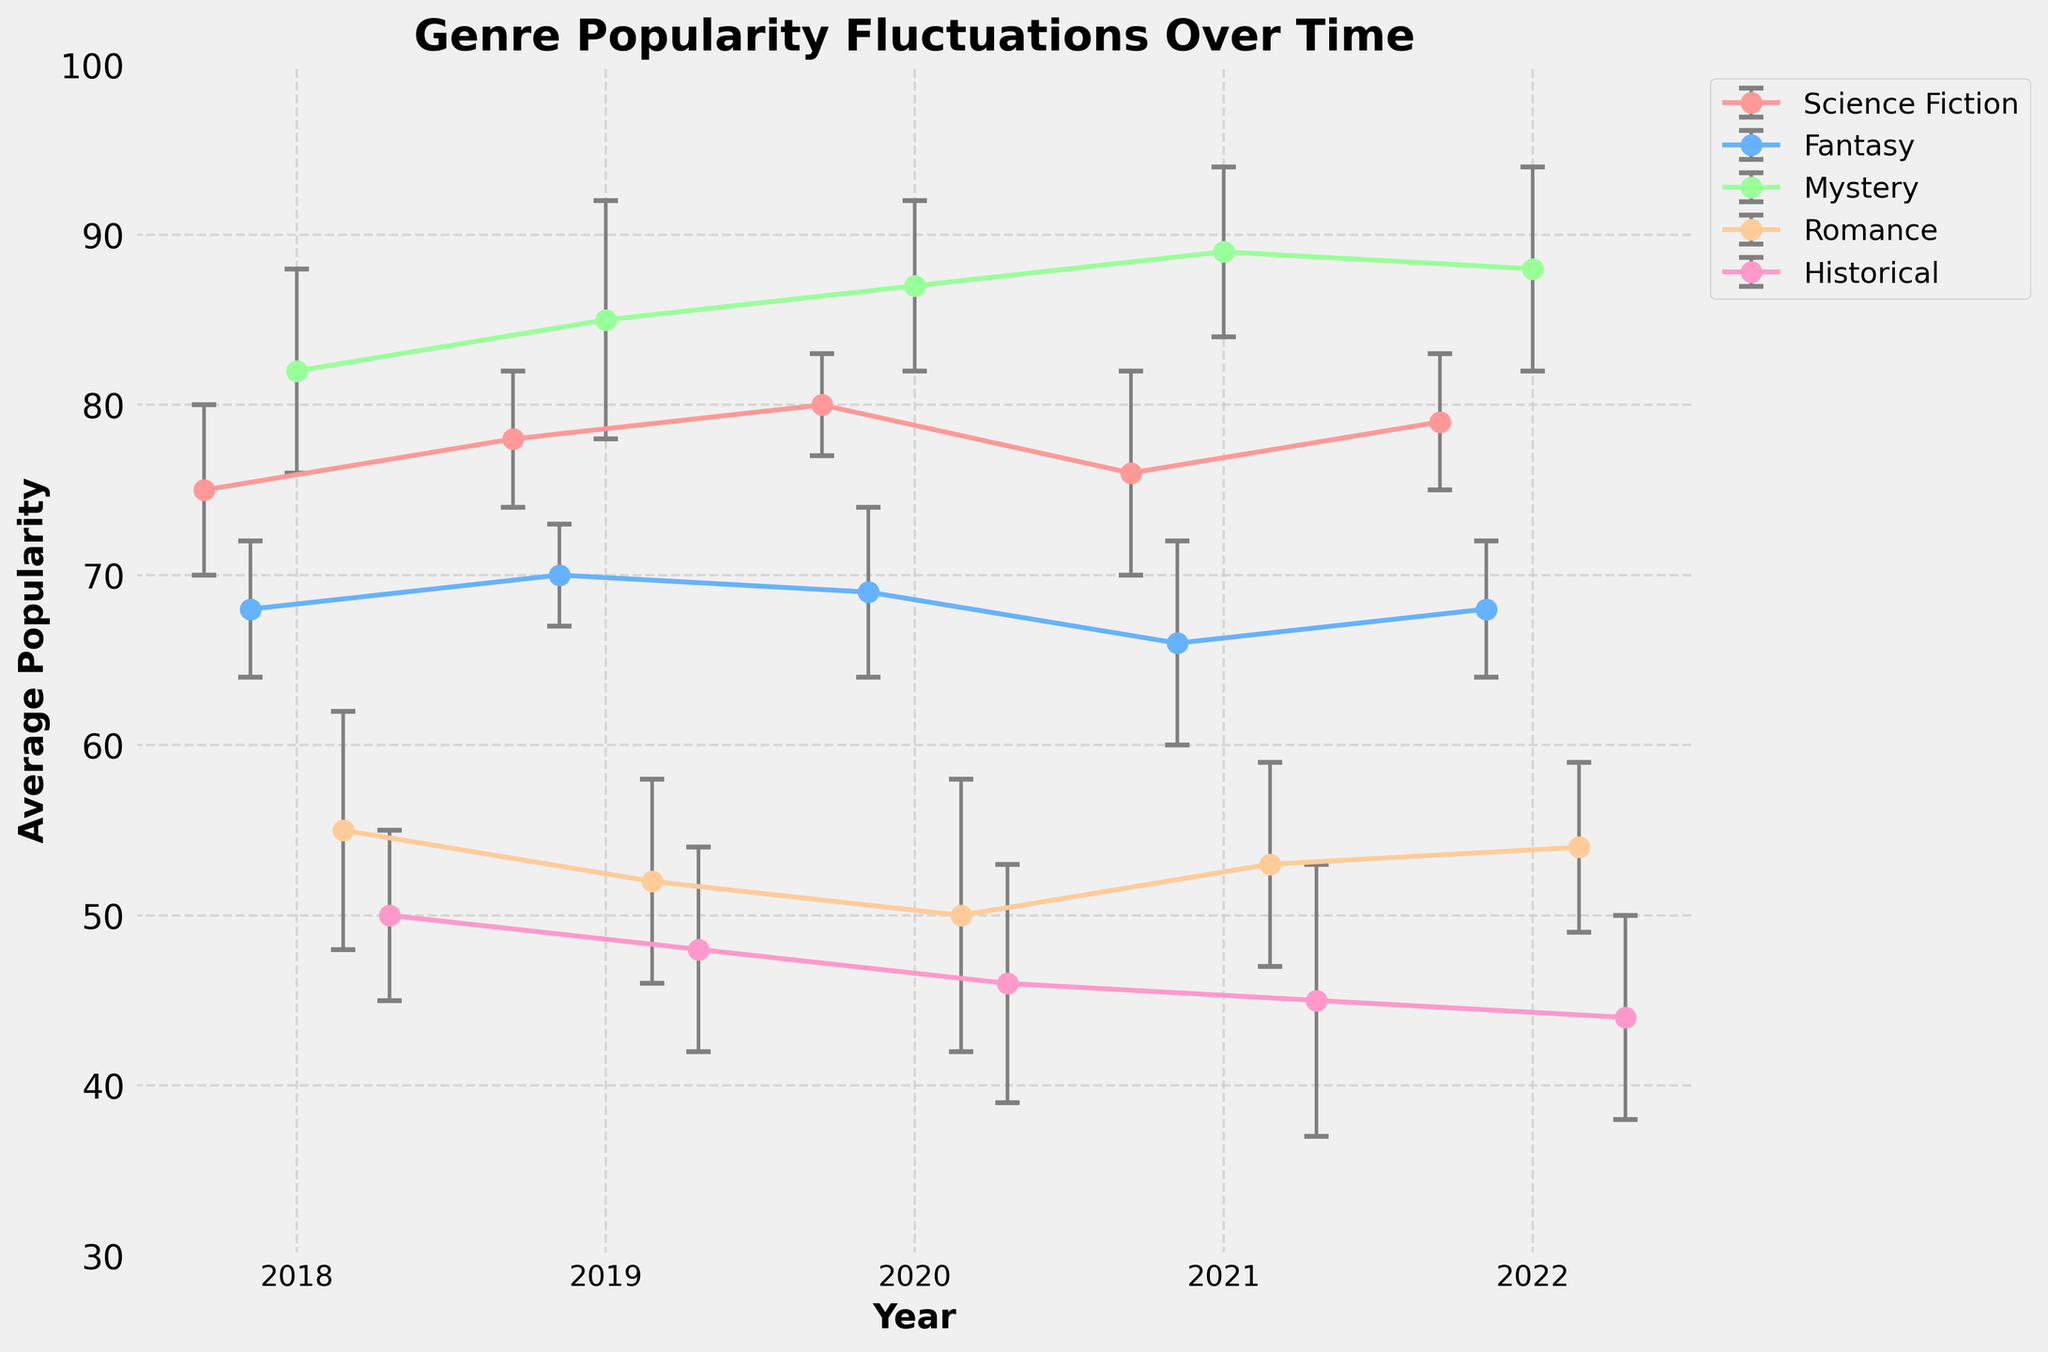What is the title of the figure? The title is at the top of the figure, reading "Genre Popularity Fluctuations Over Time."
Answer: Genre Popularity Fluctuations Over Time How many genres are displayed in the figure? There are five distinct colored lines in the figure, each representing a different genre: Science Fiction, Fantasy, Mystery, Romance, and Historical.
Answer: Five What is the range of the y-axis? The y-axis has numerical labels starting from 30 and going up to 100.
Answer: 30 to 100 What genre had the highest average popularity in 2021? Look for the highest point on the graph for the year 2021. The highest point is for Mystery, which has an average popularity of 89.
Answer: Mystery Which genre shows the most consistent popularity from 2018 to 2022 based on the error bars? The error bars represent standard deviation, indicating inconsistency. Fantasy has smaller error bars compared to the other genres, showing it is the most consistent.
Answer: Fantasy How did the popularity of Science Fiction change from 2018 to 2022? Look at the upward trend of the Science Fiction line. It increased from 75 in 2018 to 79 in 2022.
Answer: Increased Which genre had the largest decrease in average popularity from 2018 to 2022? Compare the drop in average popularity for each genre. Historical went from 50 in 2018 to 44 in 2022, a decrease of 6 points, which is the largest.
Answer: Historical What was the average popularity of Romance in 2020, and what was its standard deviation? Find the Romance line in 2020. The average popularity is 50, and the standard deviation is 8.
Answer: 50, 8 If we consider the midpoint of the average popularity range for genres in 2021, which genres are above this midpoint? The midpoint is (30 + 100) / 2 = 65. In 2021, Science Fiction, Fantasy, Mystery, and Romance are above 65.
Answer: Science Fiction, Fantasy, Mystery, Romance How did the popularity of Romance change from 2019 to 2020, and what might have contributed to this change considering the error bars? Romance's popularity decreased from 52 in 2019 to 50 in 2020, and the error bars are quite large, especially in 2020, indicating variability and possibly external factors influencing its popularity.
Answer: Decreased, large variability 